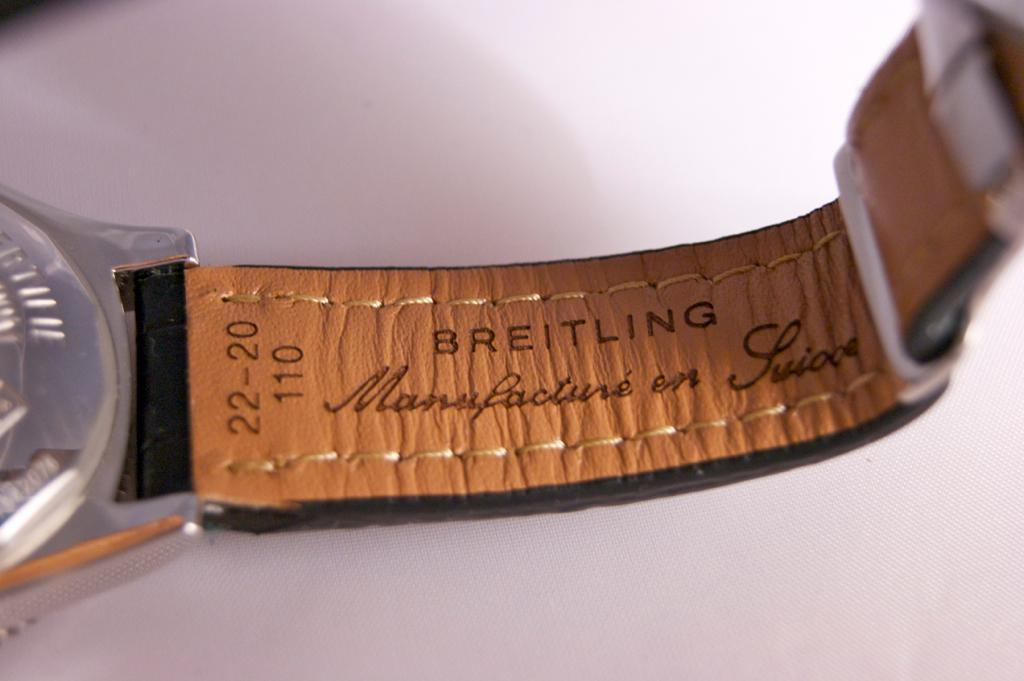Provide a one-sentence caption for the provided image. The inside of a watch band says Breitling on it. 